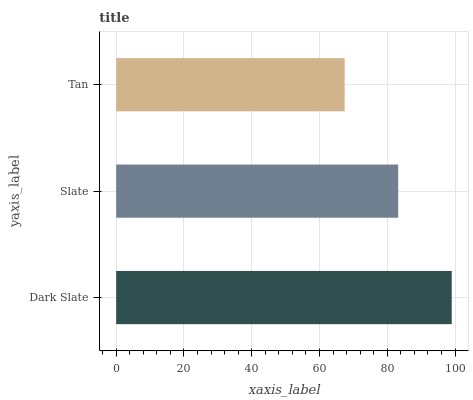Is Tan the minimum?
Answer yes or no. Yes. Is Dark Slate the maximum?
Answer yes or no. Yes. Is Slate the minimum?
Answer yes or no. No. Is Slate the maximum?
Answer yes or no. No. Is Dark Slate greater than Slate?
Answer yes or no. Yes. Is Slate less than Dark Slate?
Answer yes or no. Yes. Is Slate greater than Dark Slate?
Answer yes or no. No. Is Dark Slate less than Slate?
Answer yes or no. No. Is Slate the high median?
Answer yes or no. Yes. Is Slate the low median?
Answer yes or no. Yes. Is Tan the high median?
Answer yes or no. No. Is Dark Slate the low median?
Answer yes or no. No. 